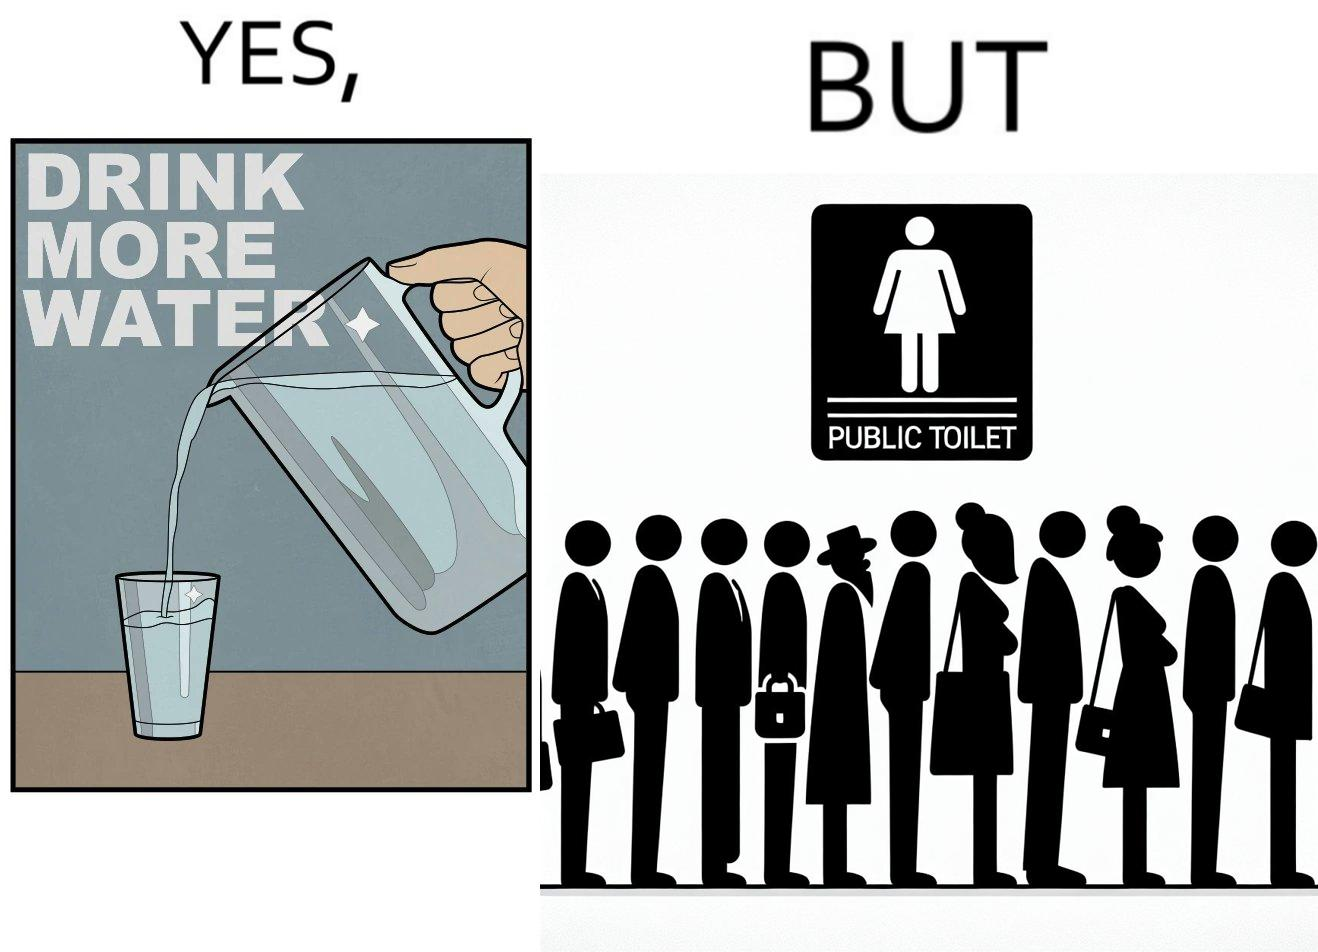Is this image satirical or non-satirical? Yes, this image is satirical. 